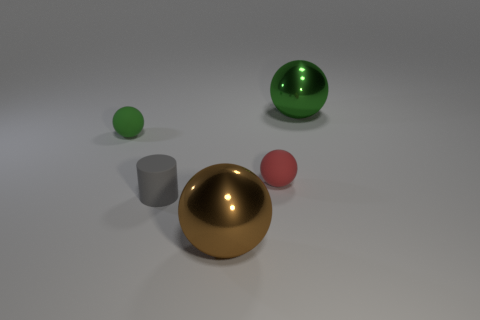What number of other things are the same size as the brown metallic ball?
Give a very brief answer. 1. How many cylinders are either large blue metallic things or red things?
Keep it short and to the point. 0. There is a green object on the right side of the tiny ball in front of the tiny rubber object that is behind the red matte ball; what is it made of?
Make the answer very short. Metal. How many big spheres are the same material as the large green object?
Provide a succinct answer. 1. Does the green sphere that is right of the brown metal ball have the same size as the small rubber cylinder?
Offer a very short reply. No. The cylinder that is made of the same material as the red object is what color?
Give a very brief answer. Gray. There is a small gray cylinder; how many metal things are right of it?
Give a very brief answer. 2. Does the large ball behind the tiny gray matte thing have the same color as the small matte ball left of the gray matte object?
Offer a terse response. Yes. The other tiny rubber thing that is the same shape as the red matte thing is what color?
Your answer should be very brief. Green. Is there any other thing that is the same shape as the gray rubber object?
Offer a terse response. No. 